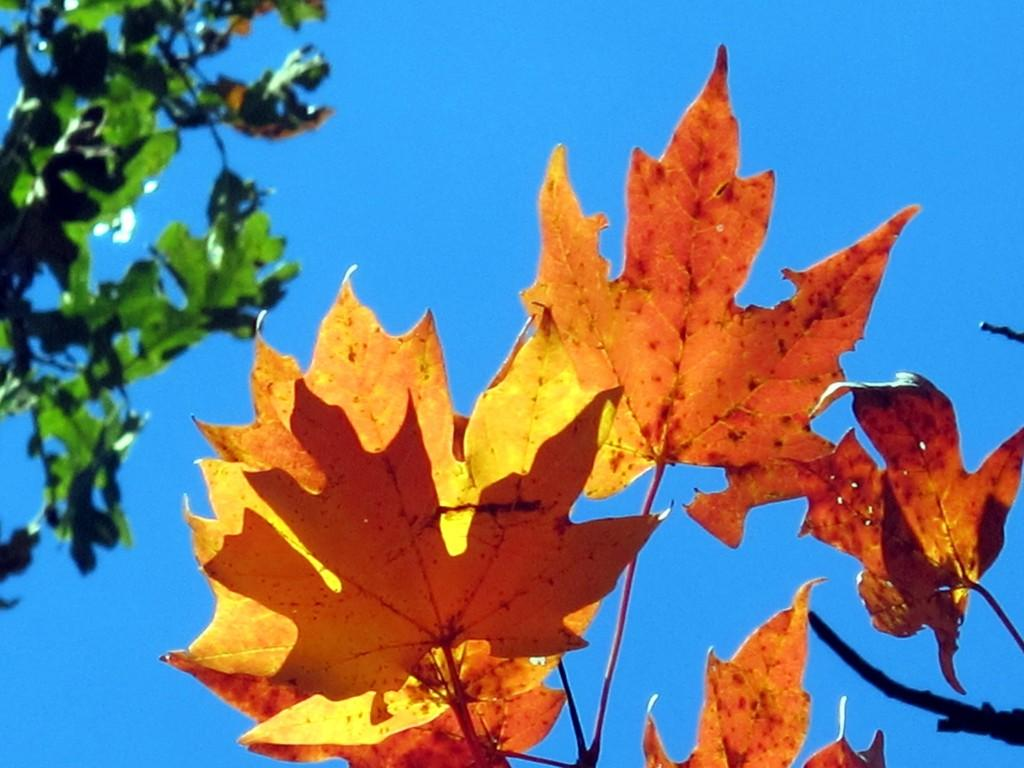What is in the foreground of the image? There are leaves and a stem in the foreground of the image. What can be seen on the right side of the image? There are branches of a tree on the right side of the image. What is visible in the background of the image? The background of the image is the sky. What type of art is displayed on the leaves in the image? There is no art displayed on the leaves in the image; it is a natural scene with leaves and branches. Is there a crown visible on the branches in the image? There is no crown present in the image; it is a tree with branches and leaves. 